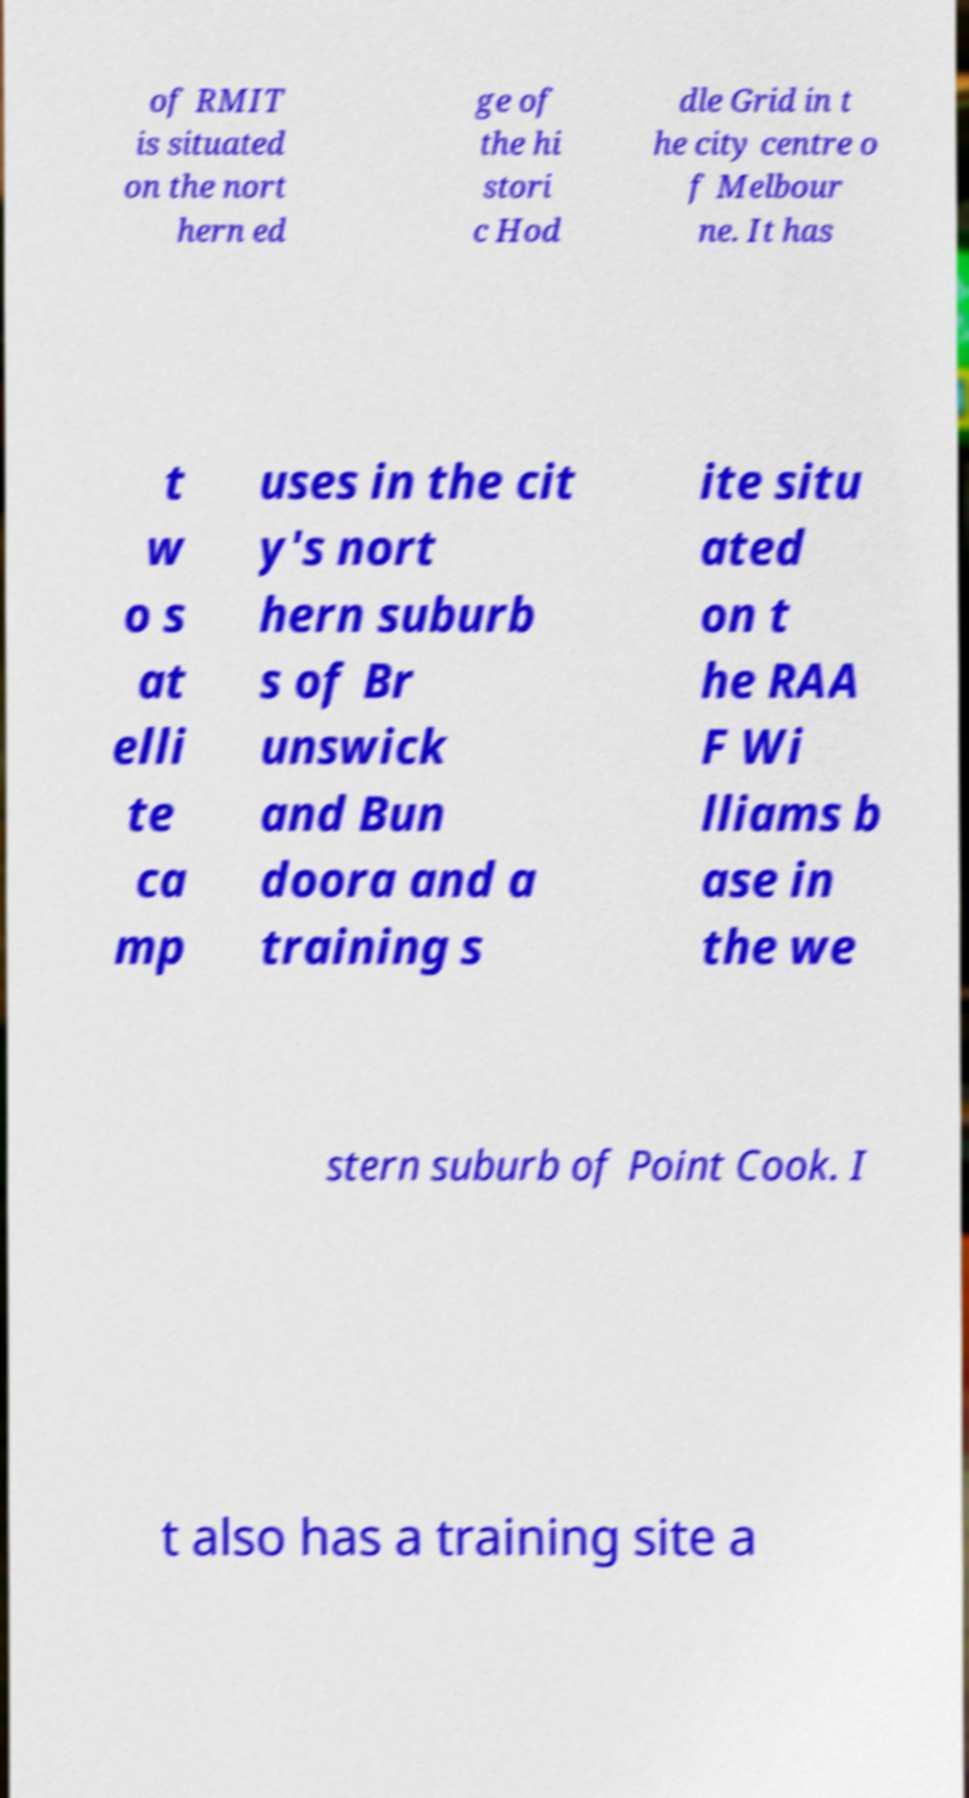There's text embedded in this image that I need extracted. Can you transcribe it verbatim? of RMIT is situated on the nort hern ed ge of the hi stori c Hod dle Grid in t he city centre o f Melbour ne. It has t w o s at elli te ca mp uses in the cit y's nort hern suburb s of Br unswick and Bun doora and a training s ite situ ated on t he RAA F Wi lliams b ase in the we stern suburb of Point Cook. I t also has a training site a 